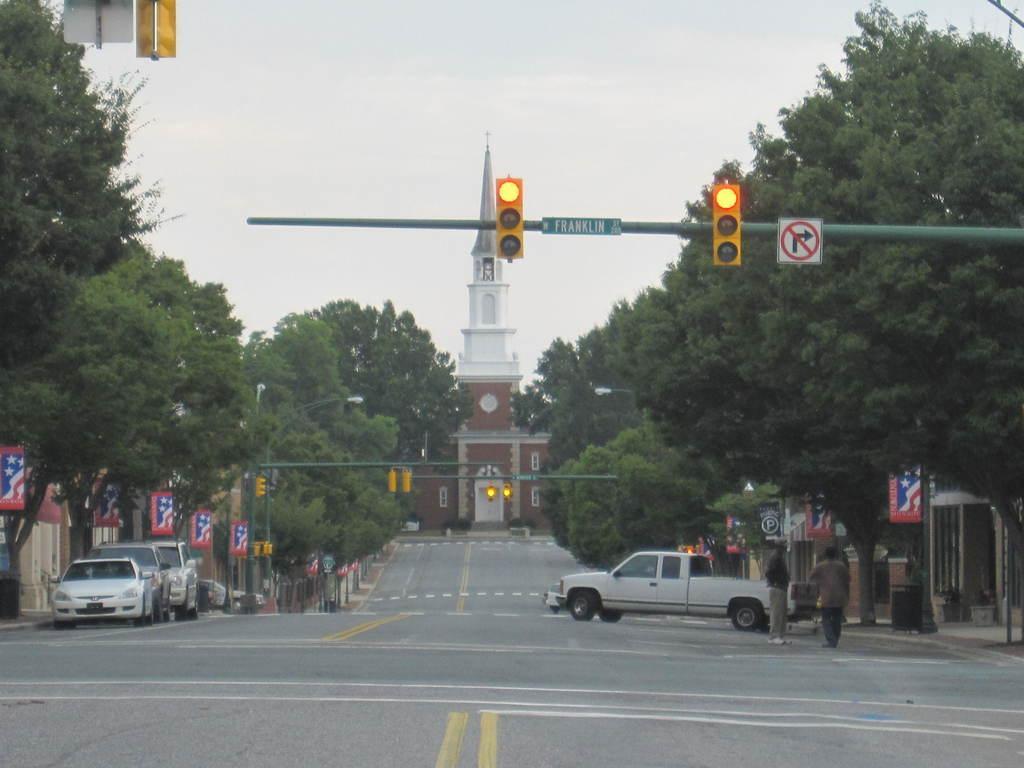Can you describe this image briefly? In this picture I can see vehicles on the road, there are boards, poles, lights, there are two persons standing, there is a tower, there are trees, and in the background there is the sky. 